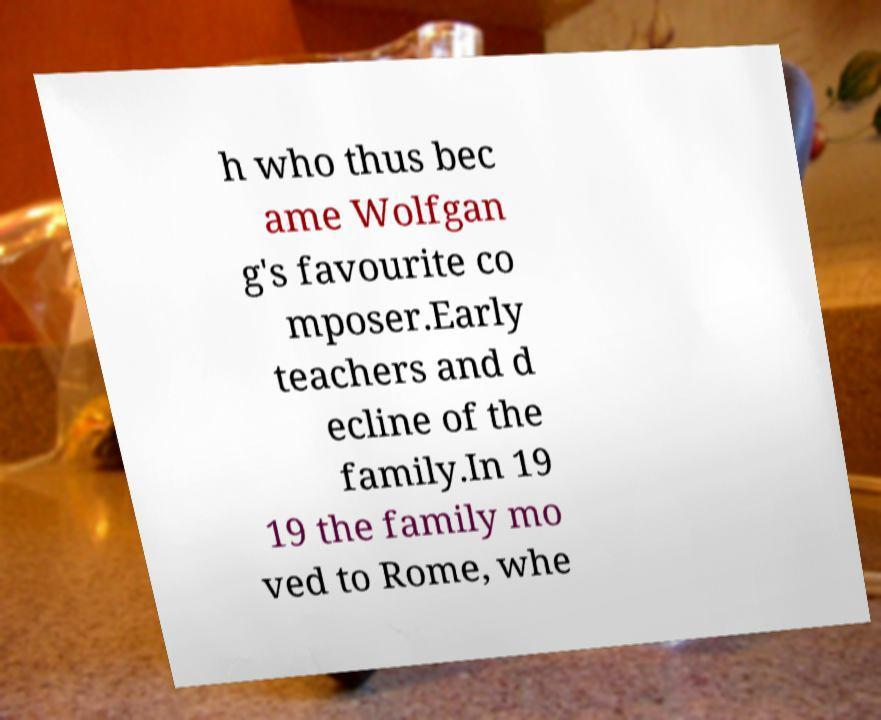I need the written content from this picture converted into text. Can you do that? h who thus bec ame Wolfgan g's favourite co mposer.Early teachers and d ecline of the family.In 19 19 the family mo ved to Rome, whe 